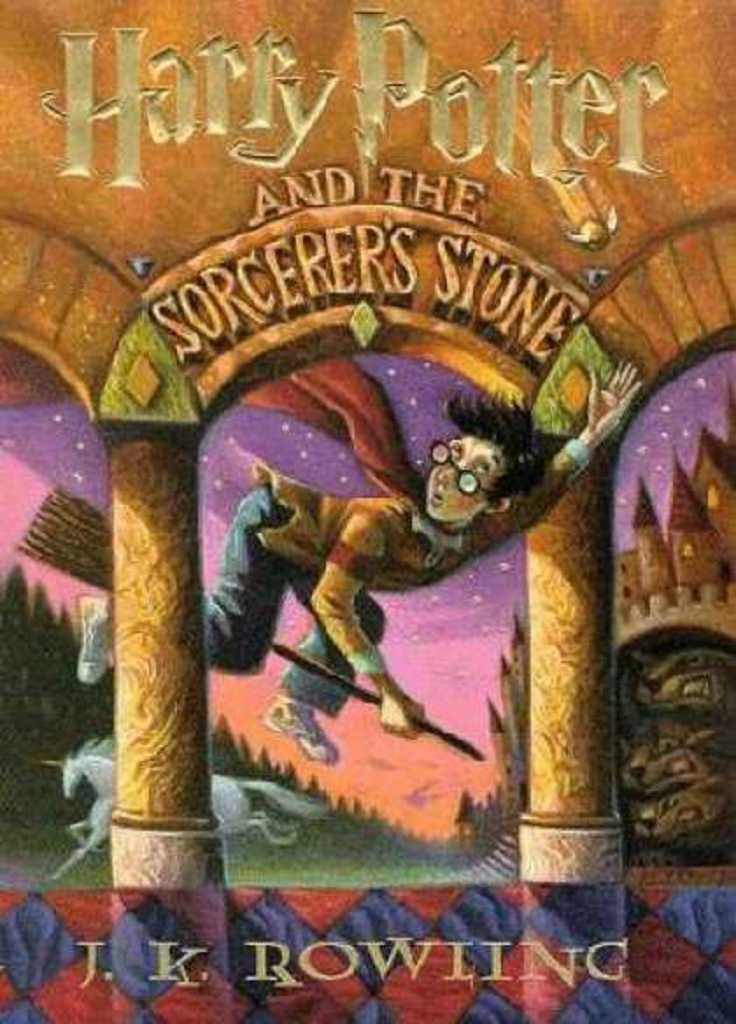<image>
Give a short and clear explanation of the subsequent image. The J.K.. Rowling book cover for Harry Potter and the Sorcerer's Stone. 